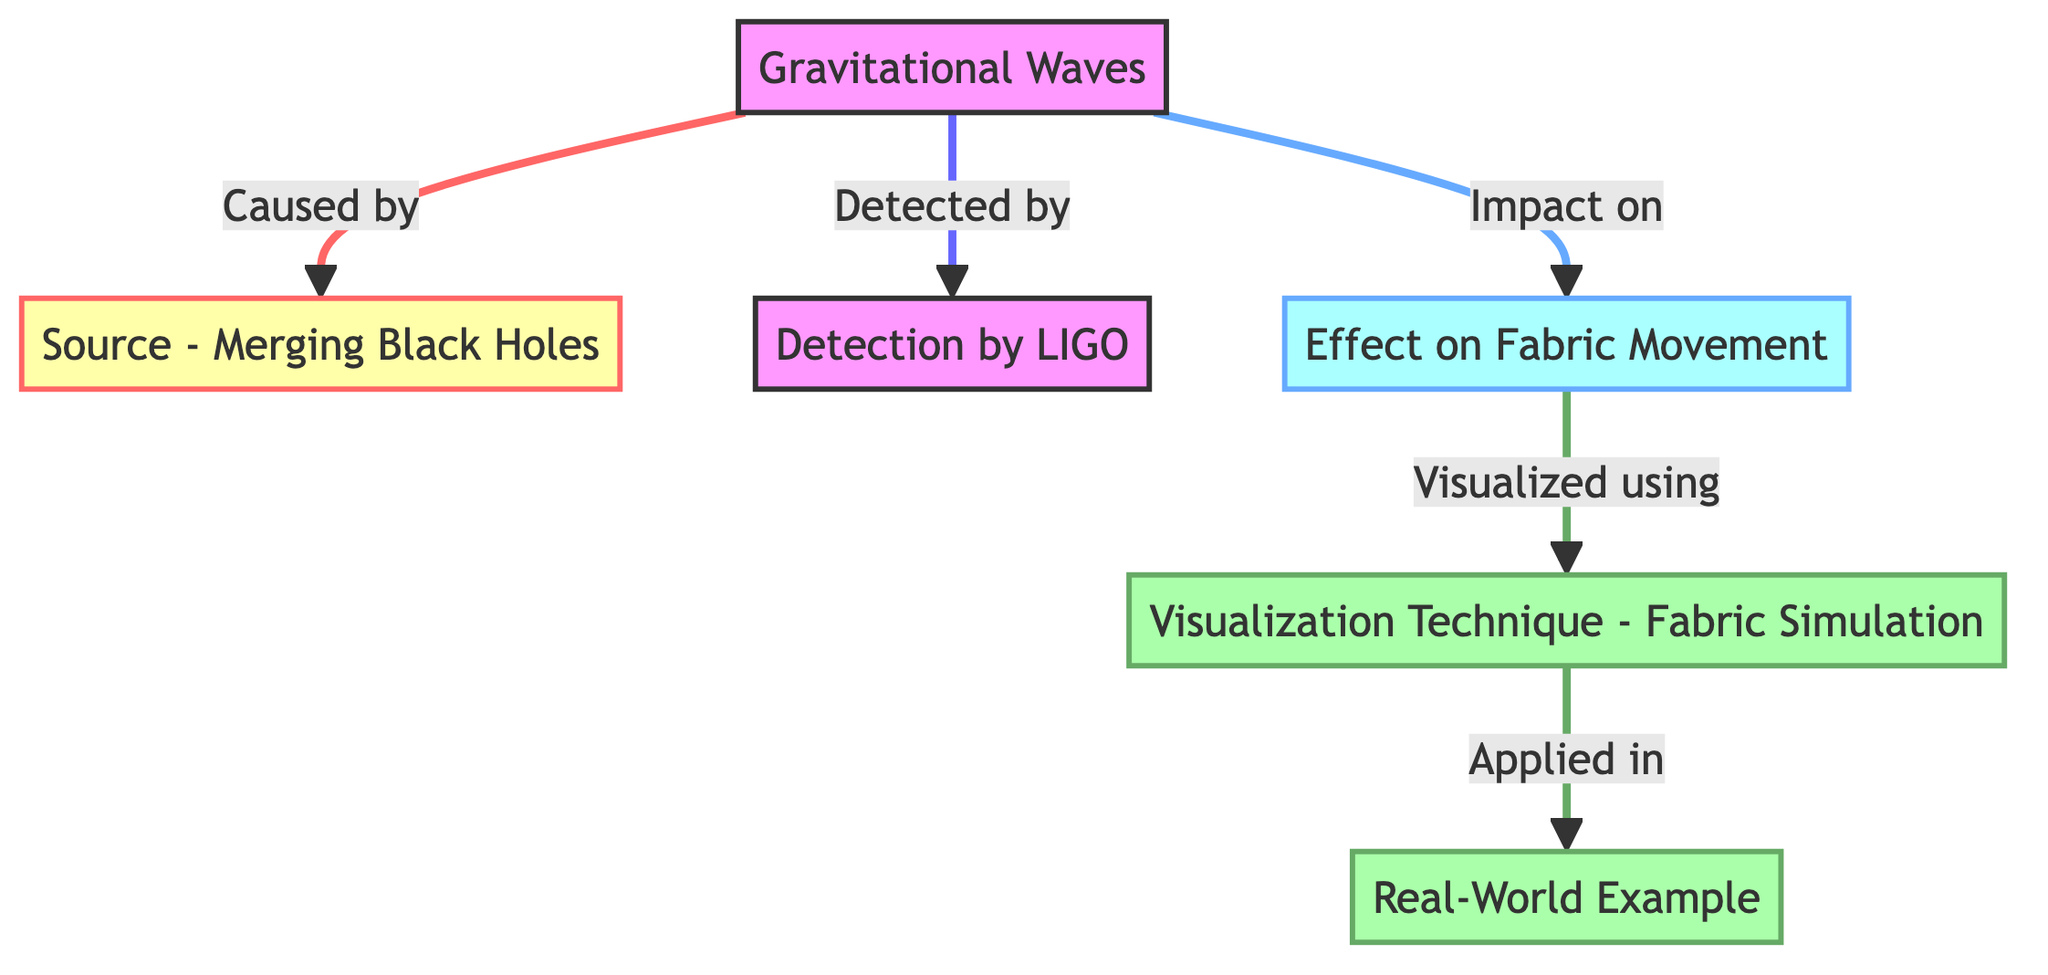What causes gravitational waves? The diagram shows that gravitational waves are caused by merging black holes. Thus, the answer is found at the origin node for gravitational waves in the flowchart.
Answer: Merging Black Holes What is detected by LIGO? According to the diagram, LIGO detects gravitational waves. This information is derived from the link connecting the node for gravitational waves and the node for detection by LIGO.
Answer: Gravitational Waves How many main nodes are present in the diagram? By counting, there are six main nodes in the diagram: Gravitational Waves, Source - Merging Black Holes, Detection by LIGO, Effect on Fabric Movement, Visualization Technique - Fabric Simulation, and Real-World Example.
Answer: Six What is the relationship between gravitational waves and fabric movement? The diagram indicates that gravitational waves impact fabric movement, found by following the arrows from the gravitational waves node to the effect on fabric movement node.
Answer: Impact on Which visualization technique is used for fabric simulation? The relevant node shows that the visualization technique is fabric simulation. By tracing the diagram from the effect on fabric movement to the visualization technique, we see the specific technique used.
Answer: Fabric Simulation What is a real-world application of the visualization technique mentioned? The last node specifies that the application is shown in the real-world example, which connects the visualization technique node to the real-world example node, thus establishing the link.
Answer: Real-World Example What impact do gravitational waves have? The diagram identifies that gravitational waves have an impact on the movement of fabrics. Hence, this connection can be directly seen in the flow from the gravitational waves node to the effect on fabric movement node.
Answer: Fabric Movement What connects the source of gravitational waves to their detection? The source of gravitational waves, which is merging black holes, is connected to their detection by LIGO as indicated by the labeled arrows between these nodes in the diagram.
Answer: LIGO 